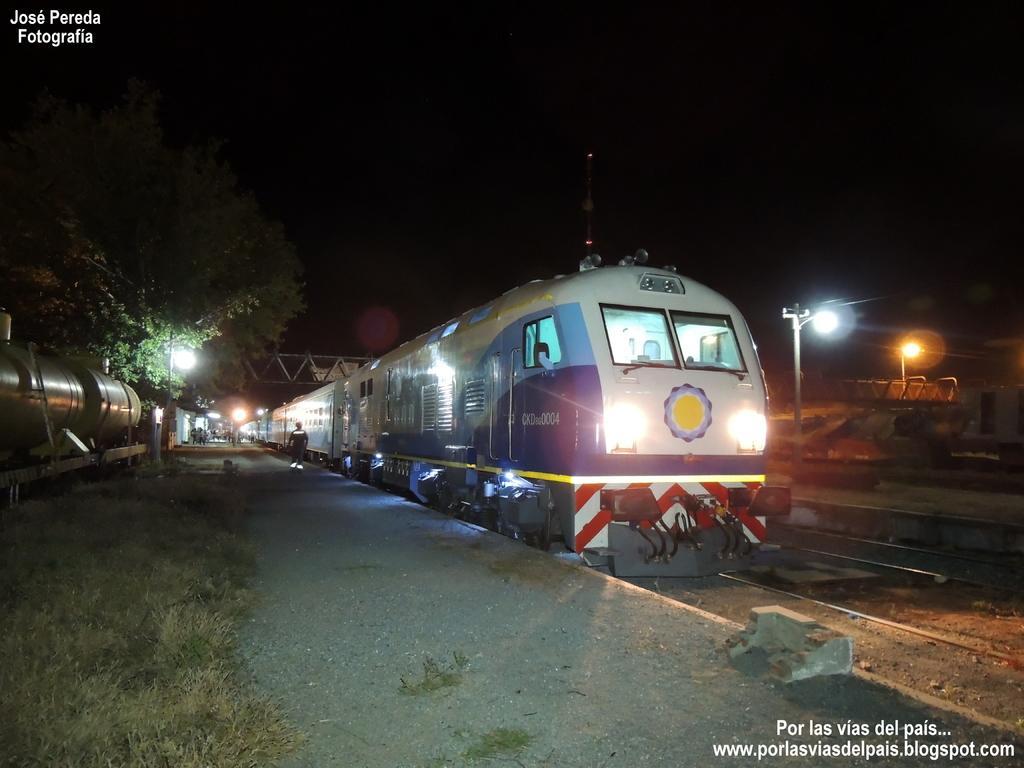How would you summarize this image in a sentence or two? In this image I can see trains and number of trees. I can also see street lights over here. I can also see a person on this platform. 